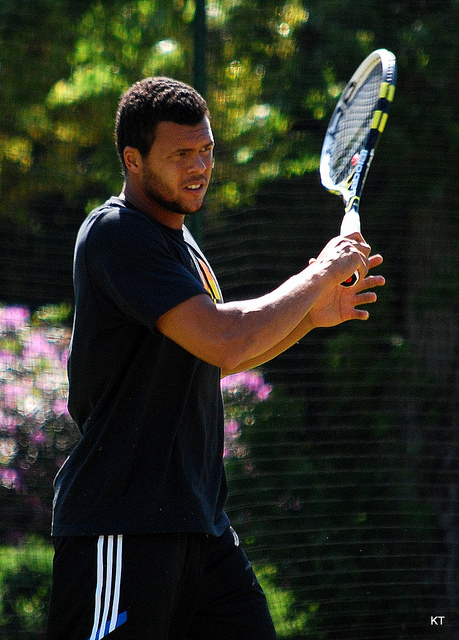Please identify all text content in this image. KT 